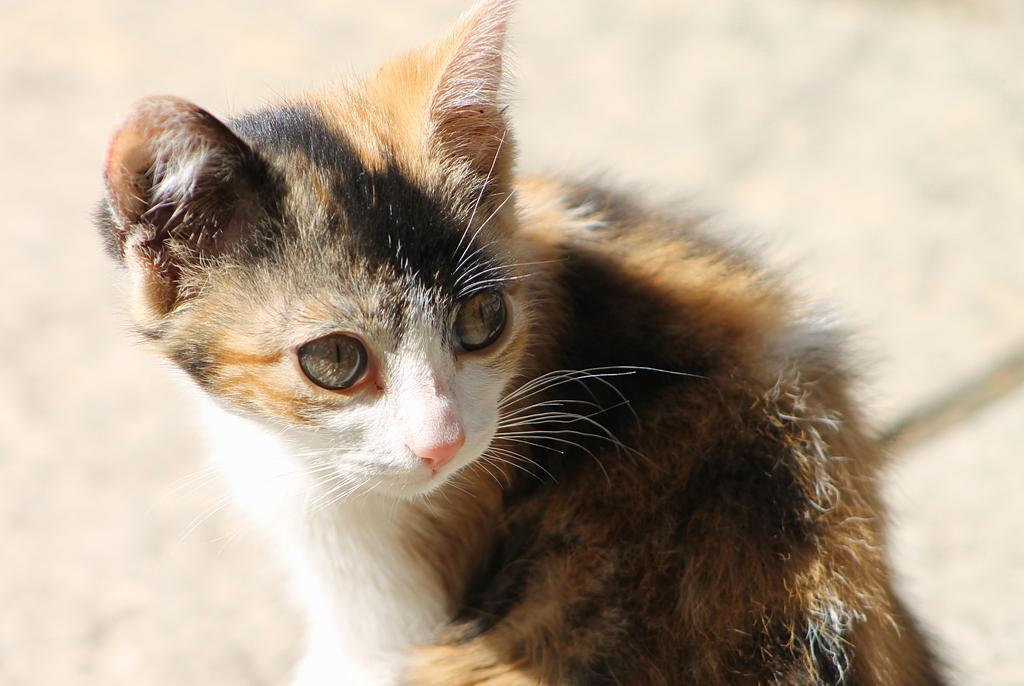What type of animal is in the image? There is a cat in the image. Where is the cat located in the image? The cat is on a surface. What type of plot is the cat involved in within the image? There is no plot depicted in the image; it simply shows a cat on a surface. How many ladybugs can be seen interacting with the cat in the image? There are no ladybugs present in the image. 